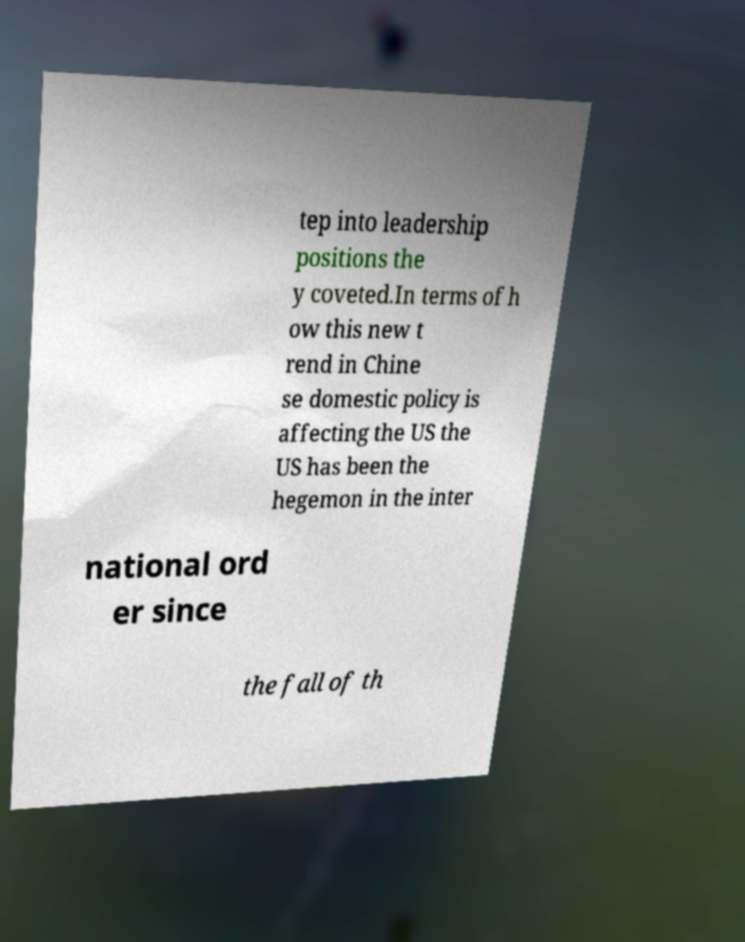There's text embedded in this image that I need extracted. Can you transcribe it verbatim? tep into leadership positions the y coveted.In terms of h ow this new t rend in Chine se domestic policy is affecting the US the US has been the hegemon in the inter national ord er since the fall of th 